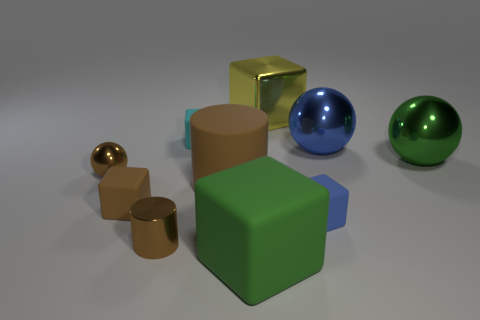Subtract 1 blocks. How many blocks are left? 4 Subtract all red cubes. Subtract all purple cylinders. How many cubes are left? 5 Subtract all spheres. How many objects are left? 7 Add 1 small brown cubes. How many small brown cubes are left? 2 Add 10 gray cylinders. How many gray cylinders exist? 10 Subtract 1 blue balls. How many objects are left? 9 Subtract all small cyan cubes. Subtract all large yellow metal cubes. How many objects are left? 8 